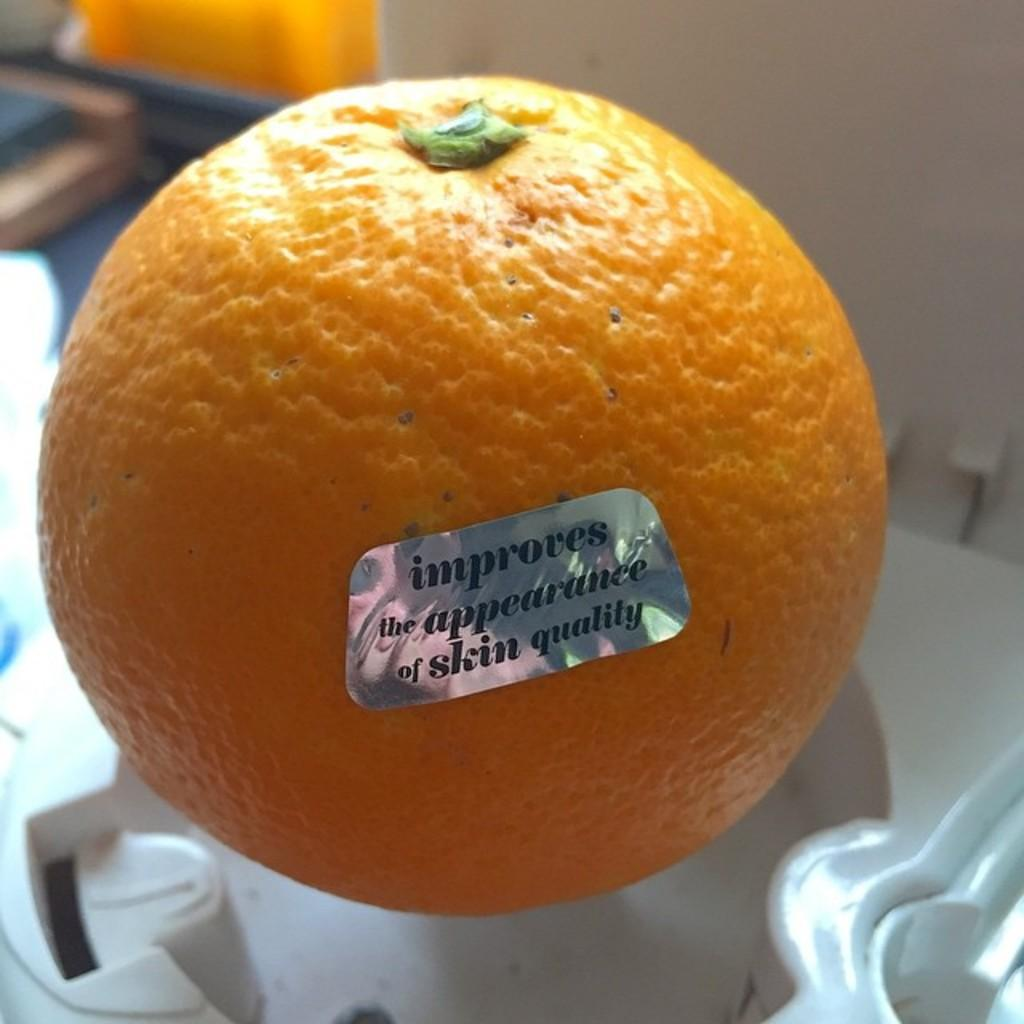Where was the image taken? The image was taken indoors. What furniture is present in the image? There is a table in the image. What object is on the table? There is an orange on the table. Is there any additional information about the orange? Yes, there is a sticker with text on the orange. How many sisters are present in the image? There are no sisters present in the image; it only features an orange with a sticker on a table. What type of cake is being served in the image? There is no cake present in the image; it only features an orange on a table. 